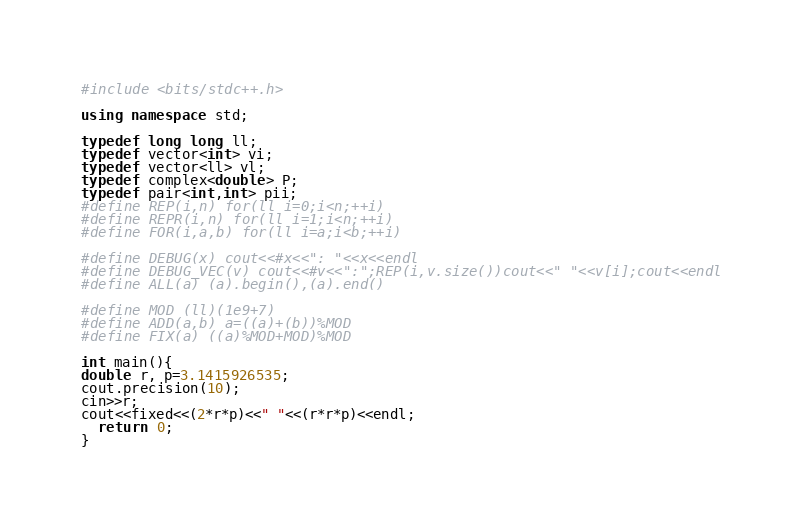Convert code to text. <code><loc_0><loc_0><loc_500><loc_500><_C++_>#include <bits/stdc++.h>

using namespace std;

typedef long long ll;
typedef vector<int> vi;
typedef vector<ll> vl;
typedef complex<double> P;
typedef pair<int,int> pii;
#define REP(i,n) for(ll i=0;i<n;++i)
#define REPR(i,n) for(ll i=1;i<n;++i)
#define FOR(i,a,b) for(ll i=a;i<b;++i)

#define DEBUG(x) cout<<#x<<": "<<x<<endl
#define DEBUG_VEC(v) cout<<#v<<":";REP(i,v.size())cout<<" "<<v[i];cout<<endl
#define ALL(a) (a).begin(),(a).end()

#define MOD (ll)(1e9+7)
#define ADD(a,b) a=((a)+(b))%MOD
#define FIX(a) ((a)%MOD+MOD)%MOD

int main(){
double r, p=3.1415926535;
cout.precision(10);
cin>>r;
cout<<fixed<<(2*r*p)<<" "<<(r*r*p)<<endl;
  return 0;
}</code> 